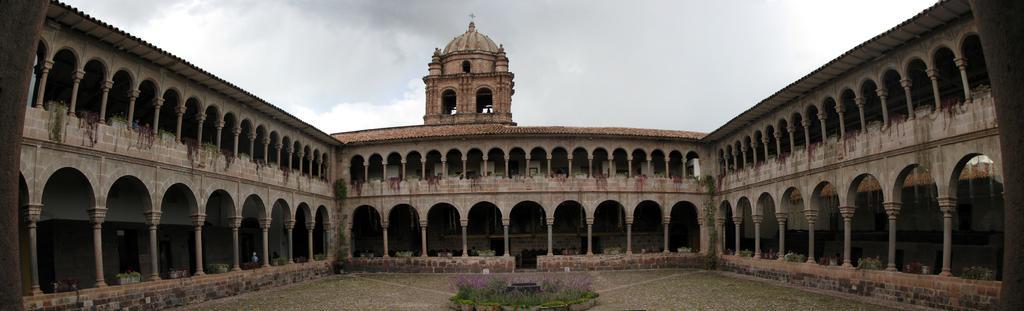Can you describe this image briefly? This picture might be taken from outside of the building. In this image, on the right side, we can see some pillars. In the middle of the image, we can see a plant with some flowers. On the left side, we can see some flower pot, plants. In the background, we can see some pillars, flower pot, plants, tower. At the top, we can see a sky which is cloudy. 